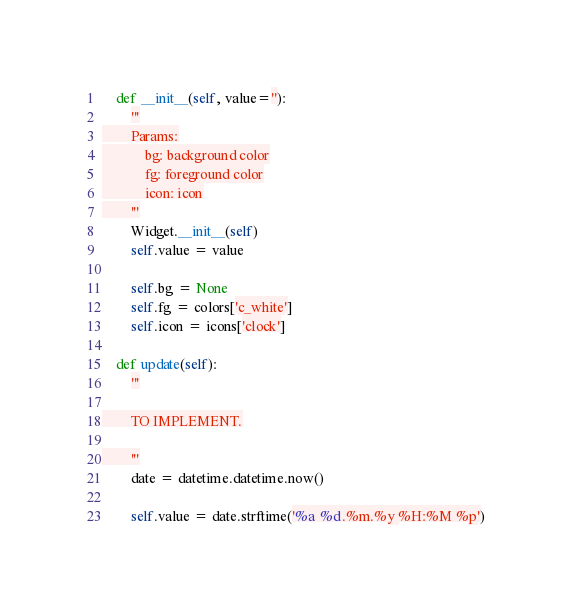Convert code to text. <code><loc_0><loc_0><loc_500><loc_500><_Python_>    def __init__(self, value=''):
        '''
        Params:
            bg: background color
            fg: foreground color
            icon: icon
        '''
        Widget.__init__(self)
        self.value = value

        self.bg = None
        self.fg = colors['c_white']
        self.icon = icons['clock']

    def update(self):
        '''

        TO IMPLEMENT.

        '''
        date = datetime.datetime.now()

        self.value = date.strftime('%a %d.%m.%y %H:%M %p')
</code> 